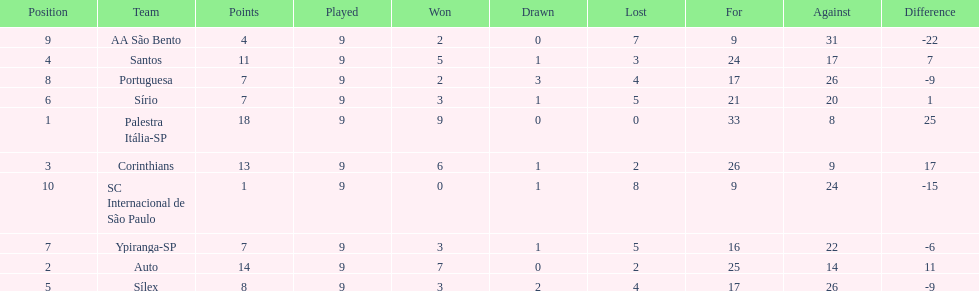In 1926 brazilian football,what was the total number of points scored? 90. 